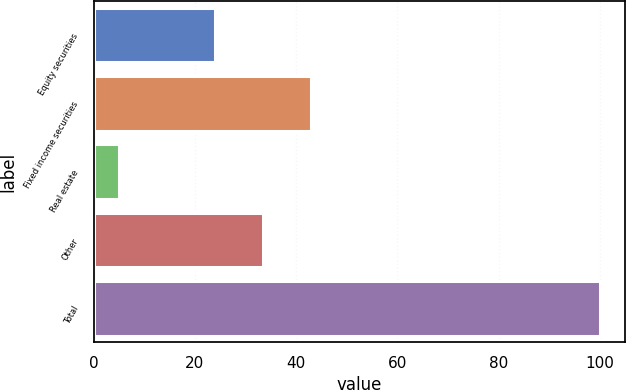<chart> <loc_0><loc_0><loc_500><loc_500><bar_chart><fcel>Equity securities<fcel>Fixed income securities<fcel>Real estate<fcel>Other<fcel>Total<nl><fcel>24<fcel>43<fcel>5<fcel>33.5<fcel>100<nl></chart> 